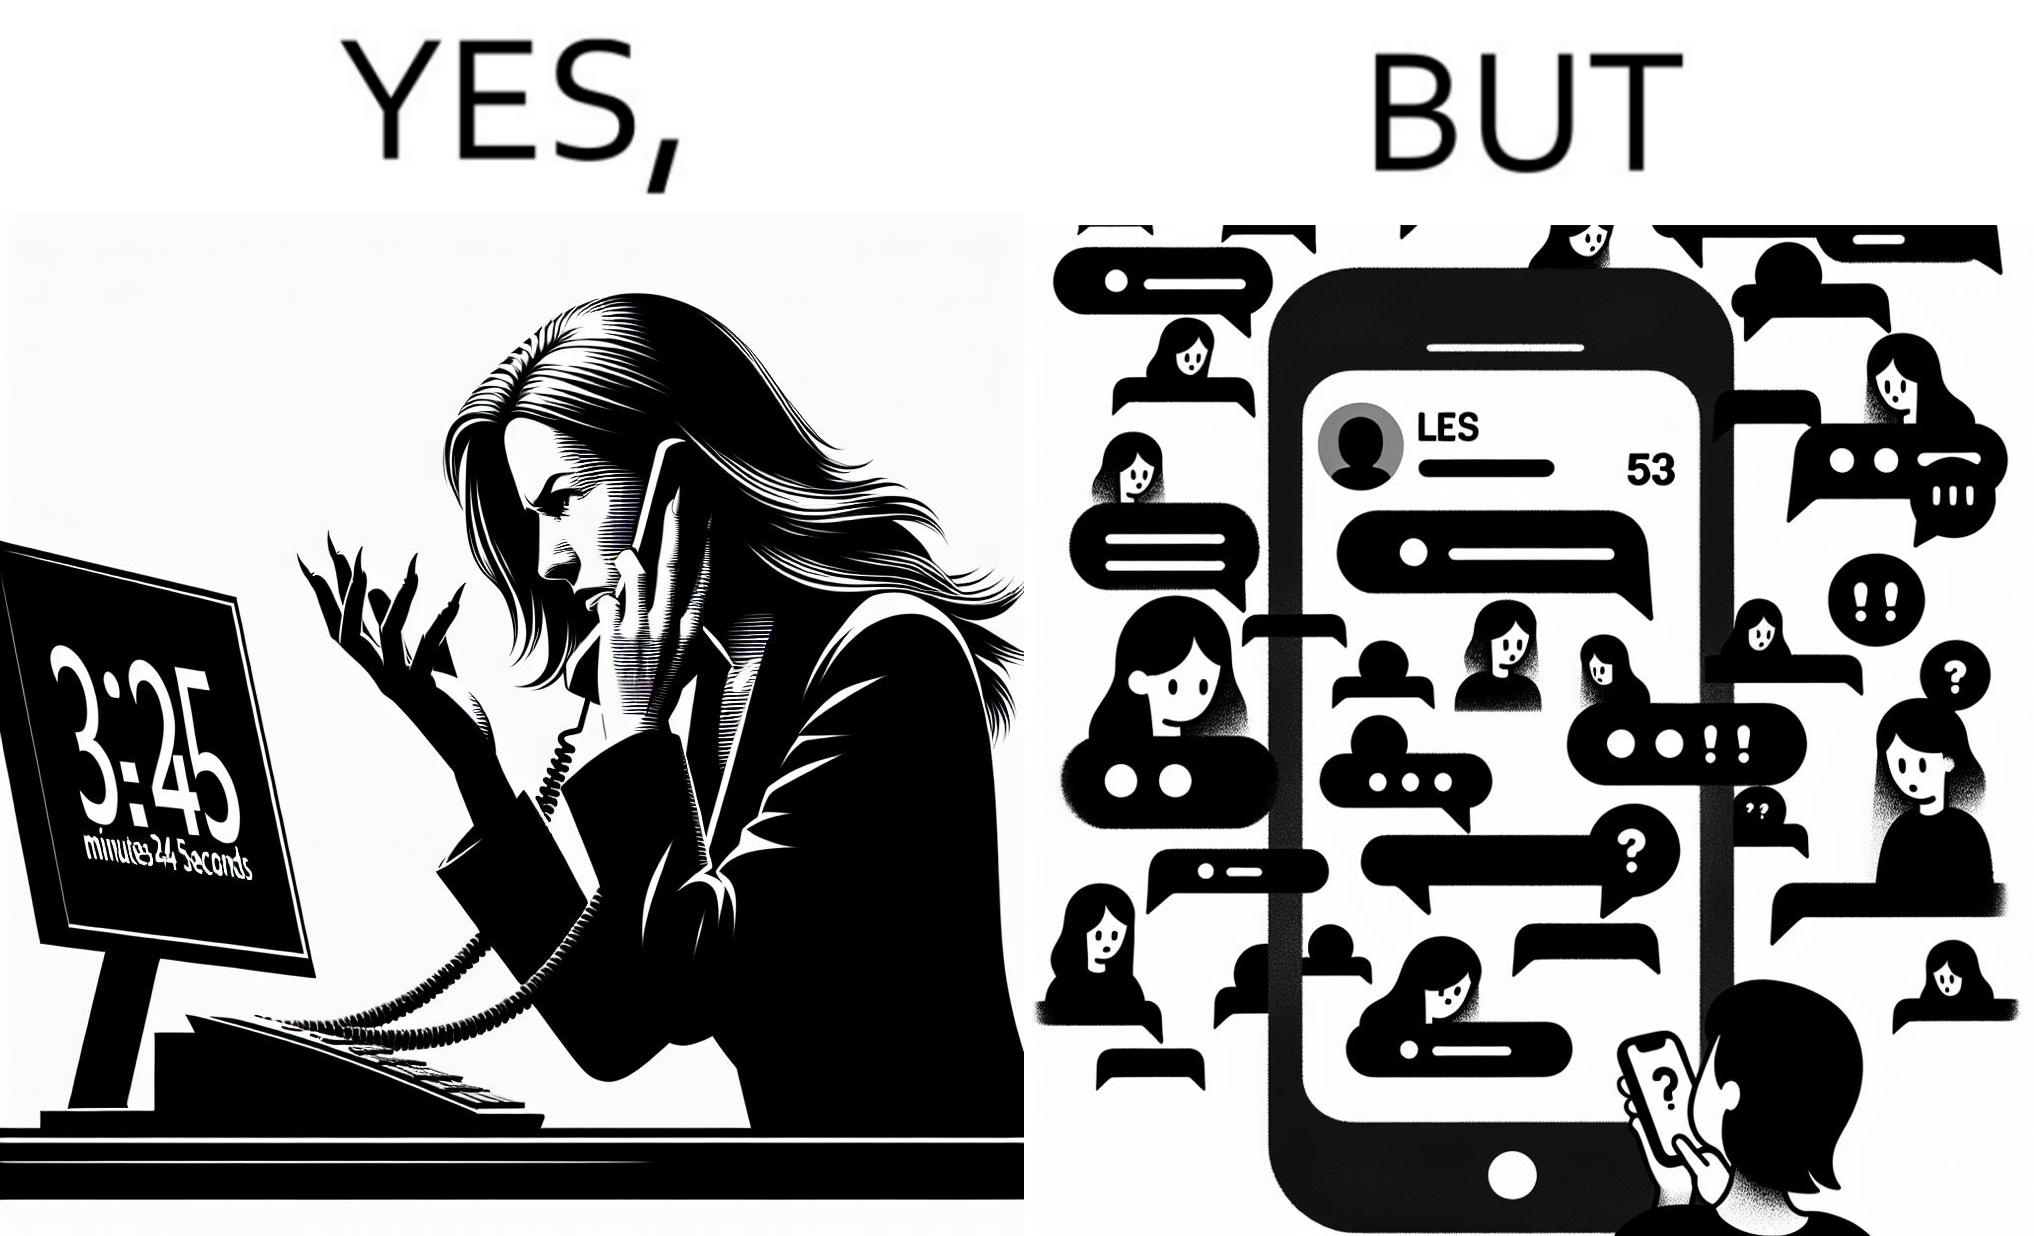Is there satirical content in this image? Yes, this image is satirical. 